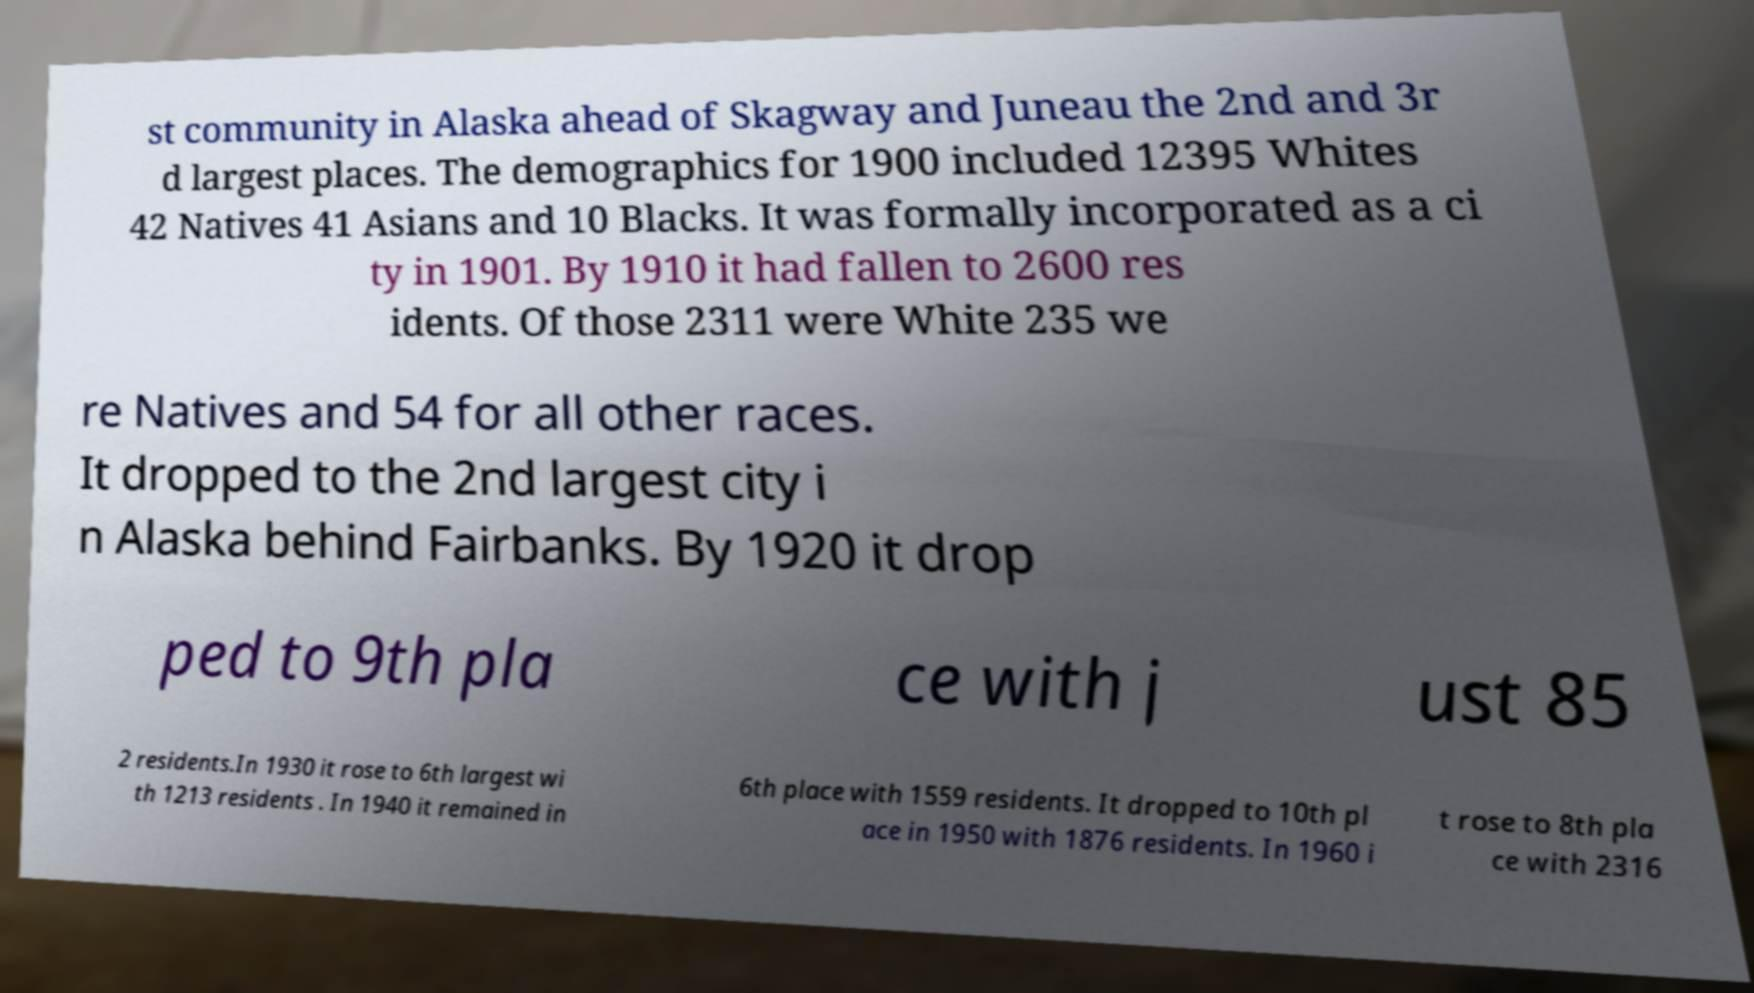Please read and relay the text visible in this image. What does it say? st community in Alaska ahead of Skagway and Juneau the 2nd and 3r d largest places. The demographics for 1900 included 12395 Whites 42 Natives 41 Asians and 10 Blacks. It was formally incorporated as a ci ty in 1901. By 1910 it had fallen to 2600 res idents. Of those 2311 were White 235 we re Natives and 54 for all other races. It dropped to the 2nd largest city i n Alaska behind Fairbanks. By 1920 it drop ped to 9th pla ce with j ust 85 2 residents.In 1930 it rose to 6th largest wi th 1213 residents . In 1940 it remained in 6th place with 1559 residents. It dropped to 10th pl ace in 1950 with 1876 residents. In 1960 i t rose to 8th pla ce with 2316 